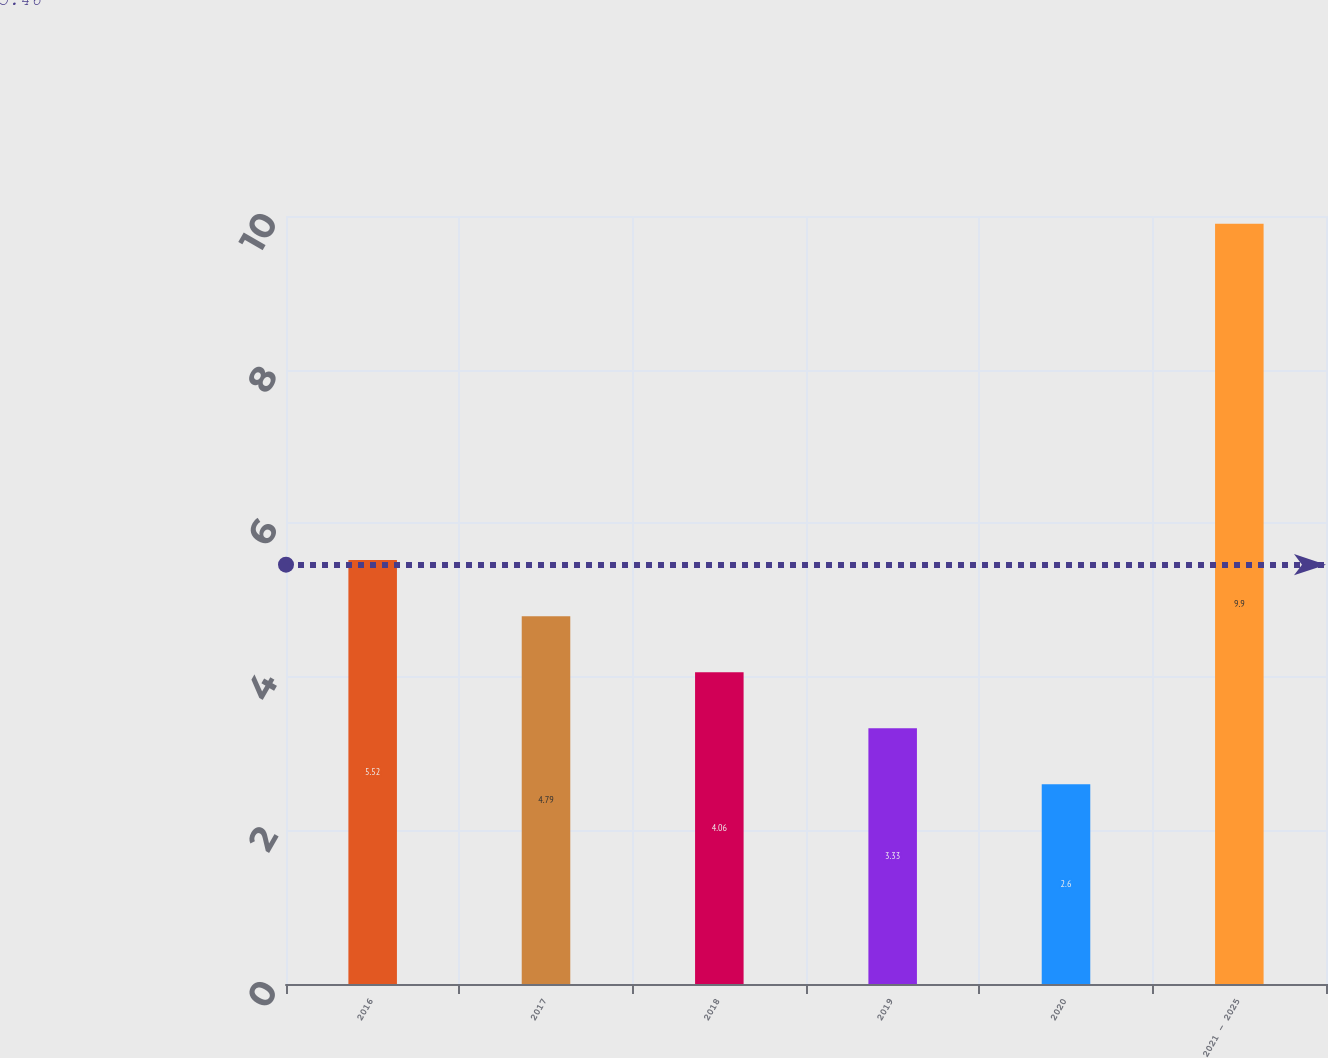Convert chart to OTSL. <chart><loc_0><loc_0><loc_500><loc_500><bar_chart><fcel>2016<fcel>2017<fcel>2018<fcel>2019<fcel>2020<fcel>2021 - 2025<nl><fcel>5.52<fcel>4.79<fcel>4.06<fcel>3.33<fcel>2.6<fcel>9.9<nl></chart> 